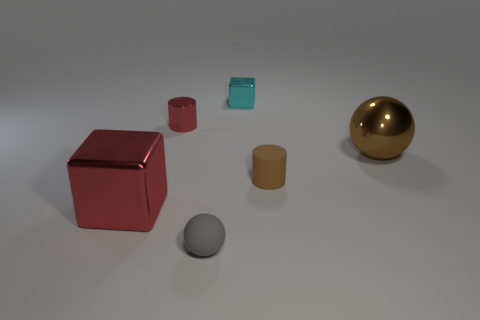What number of big brown metal things are there? There are no big brown metal objects in the image. What we see is a variety of objects in different colors, including a red cube, a gold sphere, and others of various shades and shapes. 